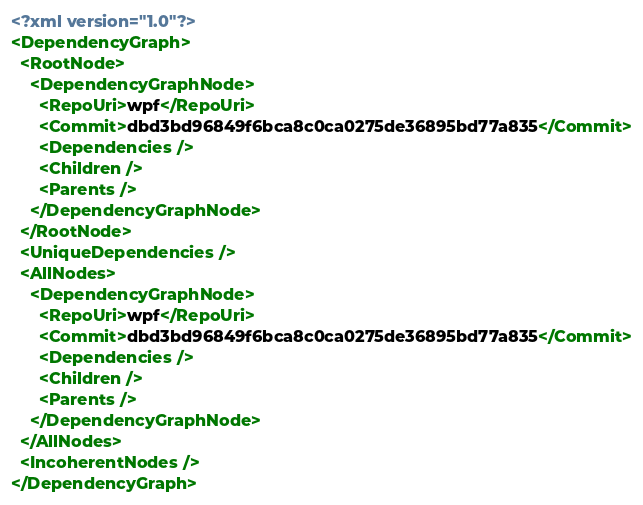<code> <loc_0><loc_0><loc_500><loc_500><_XML_><?xml version="1.0"?>
<DependencyGraph>
  <RootNode>
    <DependencyGraphNode>
      <RepoUri>wpf</RepoUri>
      <Commit>dbd3bd96849f6bca8c0ca0275de36895bd77a835</Commit>
      <Dependencies />
      <Children />
      <Parents />
    </DependencyGraphNode>
  </RootNode>
  <UniqueDependencies />
  <AllNodes>
    <DependencyGraphNode>
      <RepoUri>wpf</RepoUri>
      <Commit>dbd3bd96849f6bca8c0ca0275de36895bd77a835</Commit>
      <Dependencies />
      <Children />
      <Parents />
    </DependencyGraphNode>
  </AllNodes>
  <IncoherentNodes />
</DependencyGraph></code> 